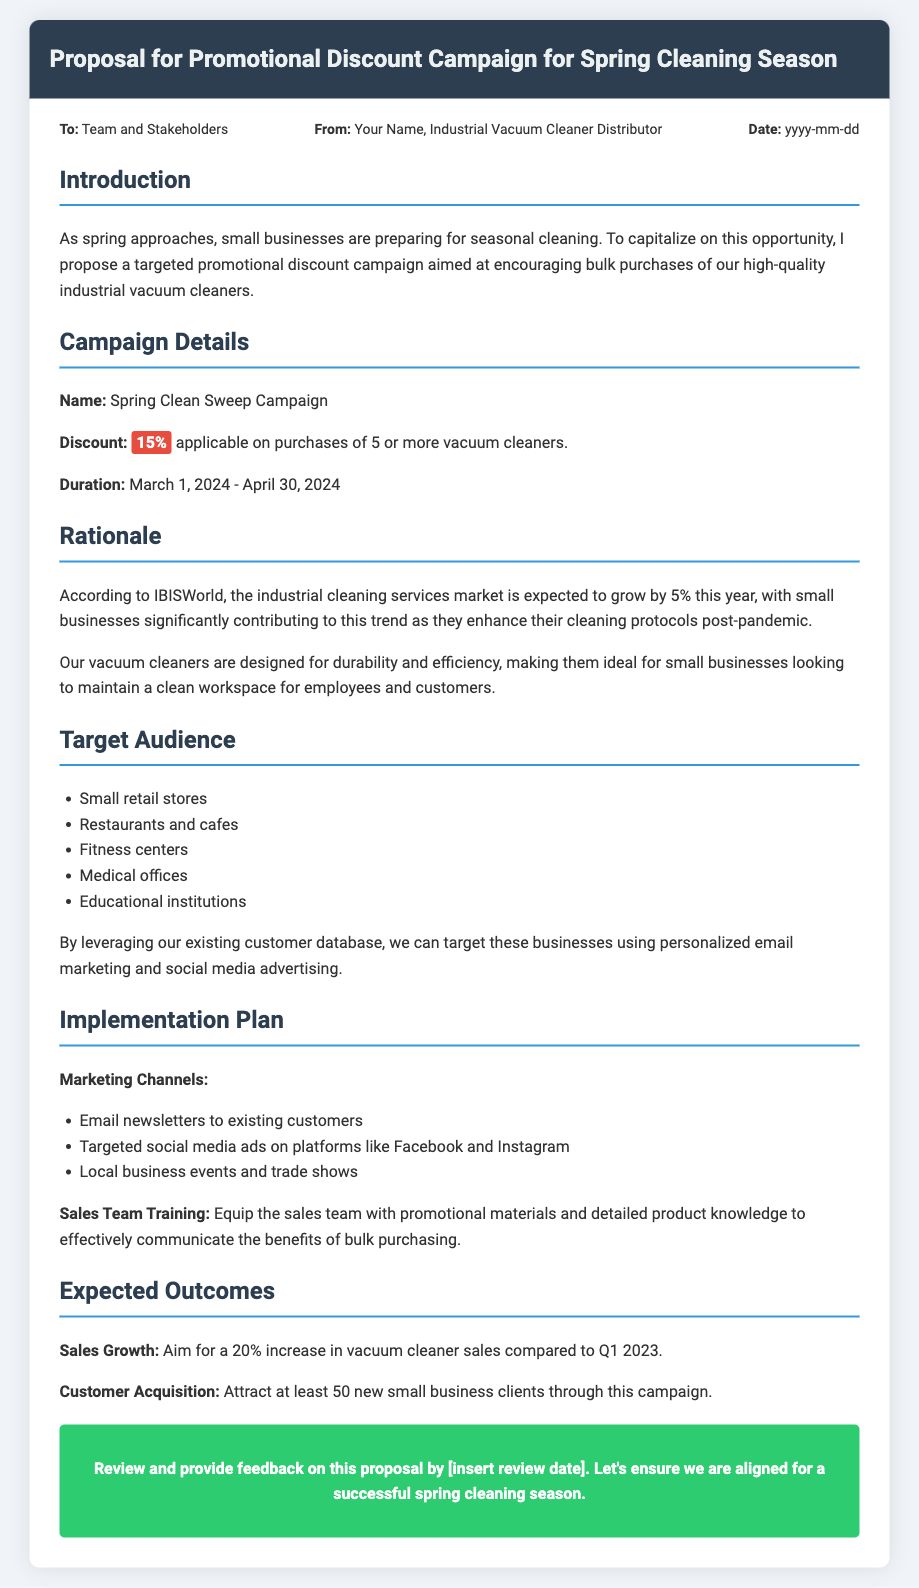What is the name of the campaign? The name of the campaign is prominently stated in the "Campaign Details" section of the document.
Answer: Spring Clean Sweep Campaign What is the discount percentage offered? The discount percentage is highlighted in the "Campaign Details" section and is stated specifically.
Answer: 15% What is the duration of the campaign? The duration of the campaign includes specific start and end dates provided in the "Campaign Details" section.
Answer: March 1, 2024 - April 30, 2024 What percentage growth in sales is the campaign aiming for? The expected sales growth is mentioned in the "Expected Outcomes" section as a target metric.
Answer: 20% What type of businesses are targeted in this campaign? The target audience is listed in the "Target Audience" section, and examples are provided there.
Answer: Small retail stores, Restaurants and cafes, Fitness centers, Medical offices, Educational institutions What marketing channels are proposed for implementation? The "Implementation Plan" section outlines various marketing channels to be utilized for the campaign.
Answer: Email newsletters, Targeted social media ads, Local business events How many new small business clients does the campaign aim to attract? The number of new clients that the campaign intends to acquire is specified in the "Expected Outcomes" section.
Answer: 50 What is the rationale behind this campaign? The rationale explains the market growth and needs highlighted in the document, indicating why the campaign is timely.
Answer: The industrial cleaning services market is expected to grow by 5% this year 